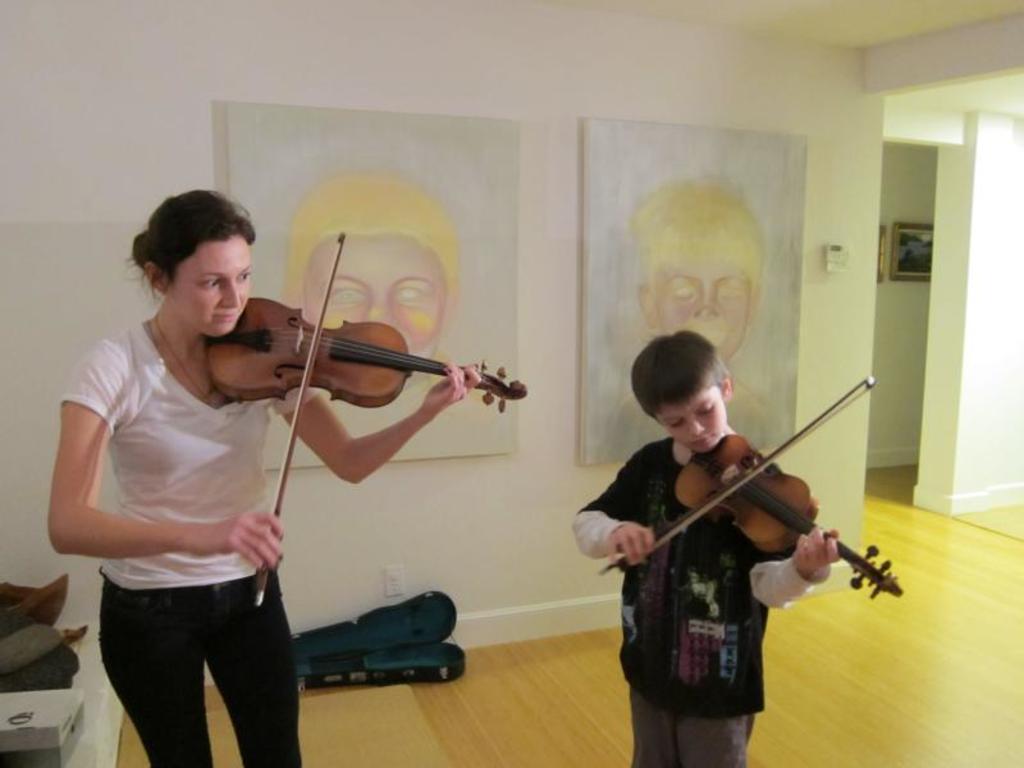In one or two sentences, can you explain what this image depicts? In this image, we can see a woman and child. They are playing music with violins. At the bottom, we can see wooden floor, box, few objects. Background there is a wall, decorative pieces, photo frame. 